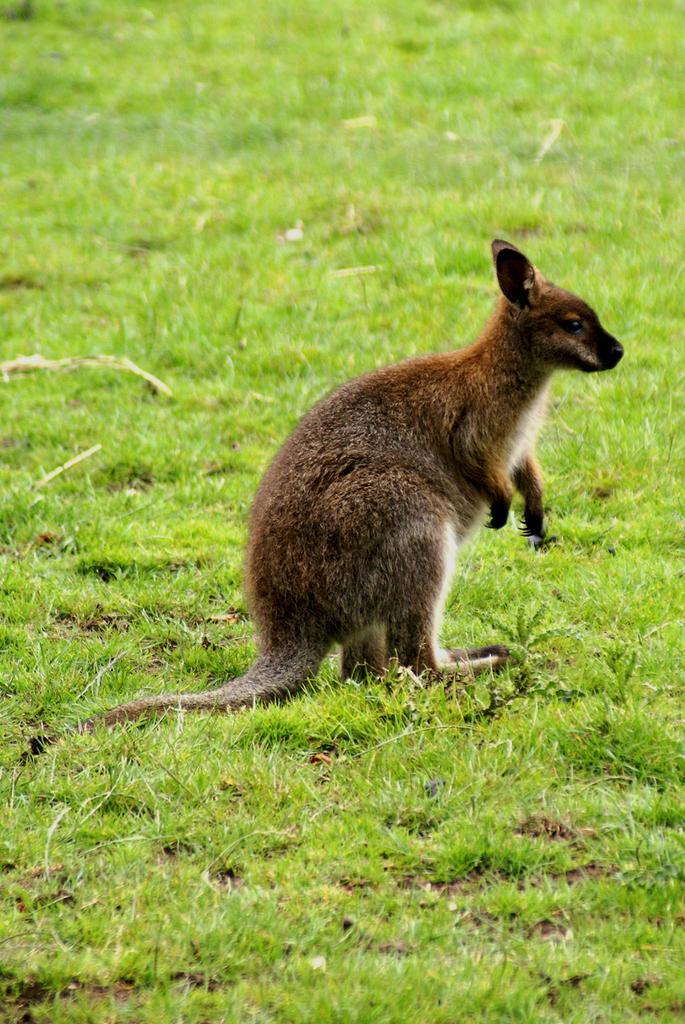Could you give a brief overview of what you see in this image? In this image there is a kangaroo on the surface of the grass. 